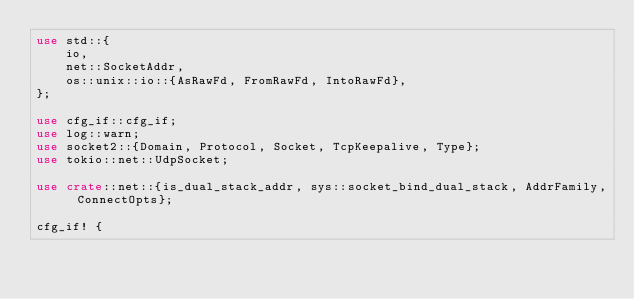<code> <loc_0><loc_0><loc_500><loc_500><_Rust_>use std::{
    io,
    net::SocketAddr,
    os::unix::io::{AsRawFd, FromRawFd, IntoRawFd},
};

use cfg_if::cfg_if;
use log::warn;
use socket2::{Domain, Protocol, Socket, TcpKeepalive, Type};
use tokio::net::UdpSocket;

use crate::net::{is_dual_stack_addr, sys::socket_bind_dual_stack, AddrFamily, ConnectOpts};

cfg_if! {</code> 